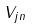Convert formula to latex. <formula><loc_0><loc_0><loc_500><loc_500>V _ { j n }</formula> 